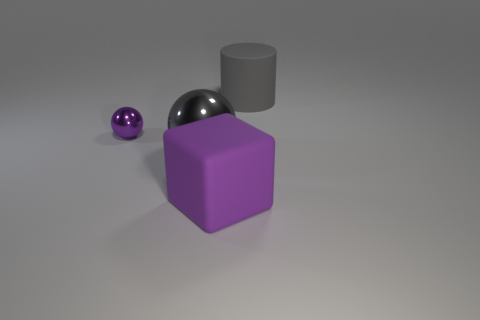Add 4 large metal balls. How many objects exist? 8 Subtract 2 balls. How many balls are left? 0 Subtract all cubes. How many objects are left? 3 Subtract all green cylinders. Subtract all blue balls. How many cylinders are left? 1 Subtract all yellow things. Subtract all small purple shiny spheres. How many objects are left? 3 Add 4 large cylinders. How many large cylinders are left? 5 Add 3 large gray shiny things. How many large gray shiny things exist? 4 Subtract 1 gray cylinders. How many objects are left? 3 